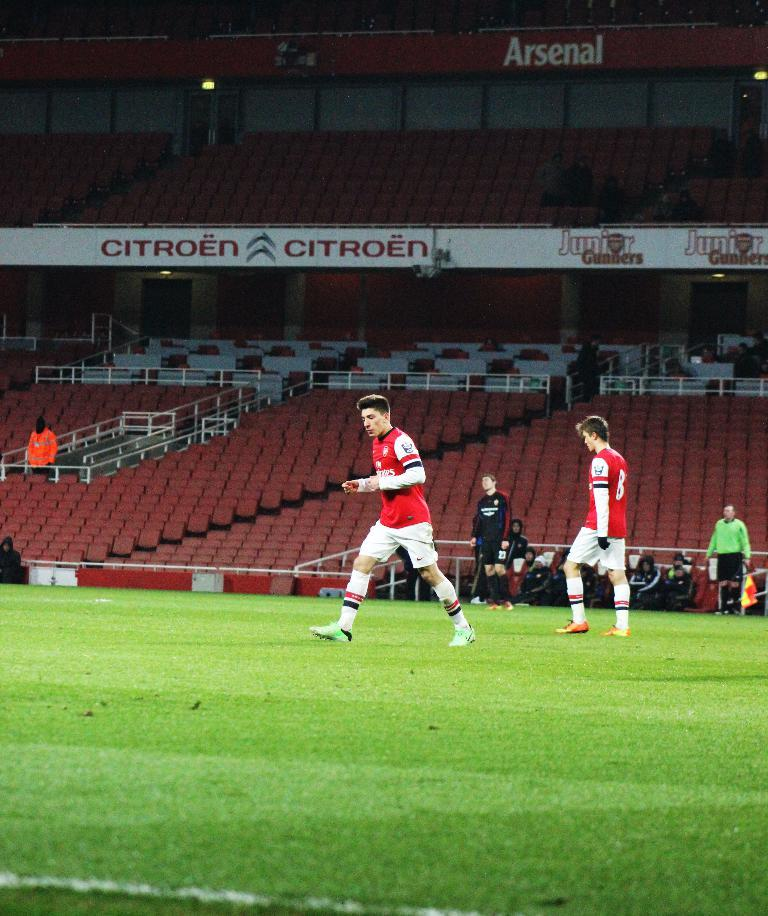Provide a one-sentence caption for the provided image. The soccer team in red is sponsored by Emirates airlines. 